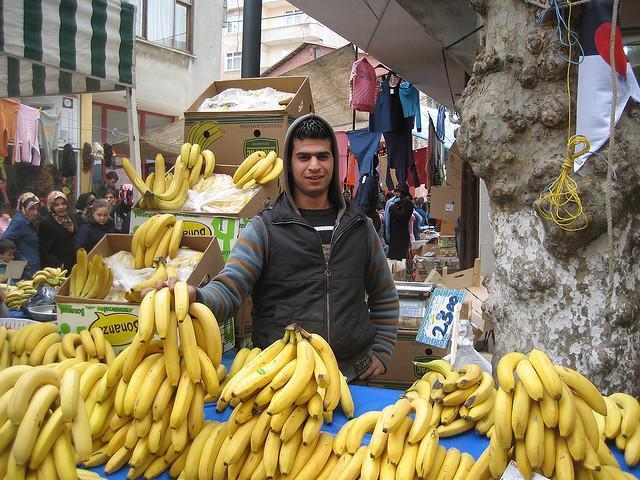How many bananas can be seen?
Give a very brief answer. 8. How many people can you see?
Give a very brief answer. 3. How many umbrellas are red?
Give a very brief answer. 0. 